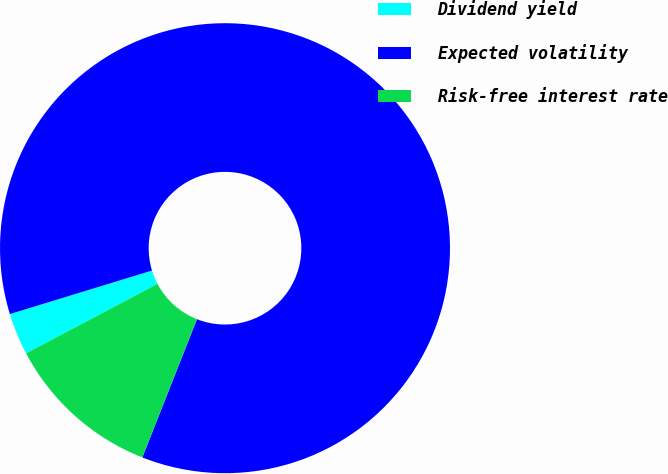Convert chart to OTSL. <chart><loc_0><loc_0><loc_500><loc_500><pie_chart><fcel>Dividend yield<fcel>Expected volatility<fcel>Risk-free interest rate<nl><fcel>3.01%<fcel>85.72%<fcel>11.27%<nl></chart> 